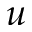<formula> <loc_0><loc_0><loc_500><loc_500>u</formula> 